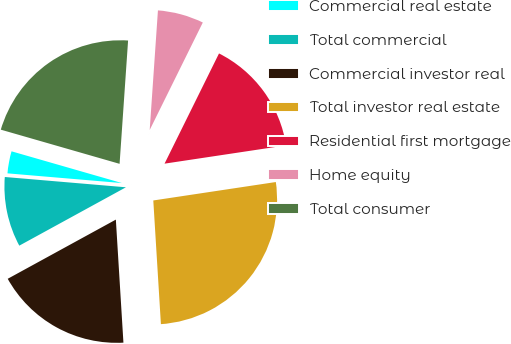<chart> <loc_0><loc_0><loc_500><loc_500><pie_chart><fcel>Commercial real estate<fcel>Total commercial<fcel>Commercial investor real<fcel>Total investor real estate<fcel>Residential first mortgage<fcel>Home equity<fcel>Total consumer<nl><fcel>3.11%<fcel>9.32%<fcel>18.01%<fcel>26.4%<fcel>15.32%<fcel>6.21%<fcel>21.64%<nl></chart> 